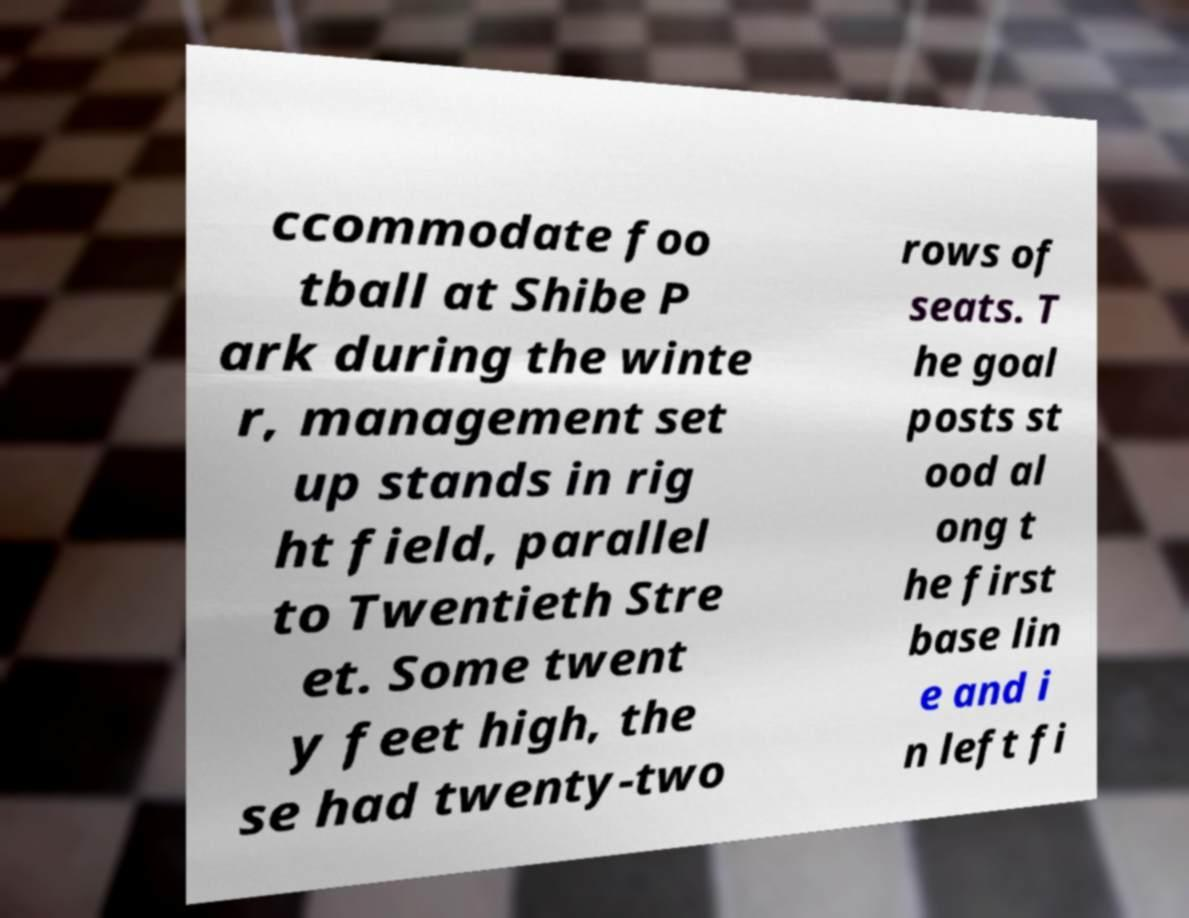Could you assist in decoding the text presented in this image and type it out clearly? ccommodate foo tball at Shibe P ark during the winte r, management set up stands in rig ht field, parallel to Twentieth Stre et. Some twent y feet high, the se had twenty-two rows of seats. T he goal posts st ood al ong t he first base lin e and i n left fi 